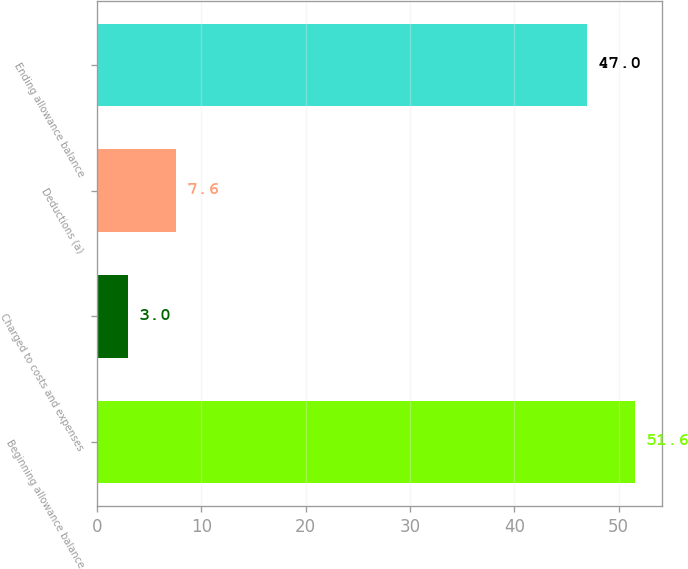Convert chart. <chart><loc_0><loc_0><loc_500><loc_500><bar_chart><fcel>Beginning allowance balance<fcel>Charged to costs and expenses<fcel>Deductions (a)<fcel>Ending allowance balance<nl><fcel>51.6<fcel>3<fcel>7.6<fcel>47<nl></chart> 